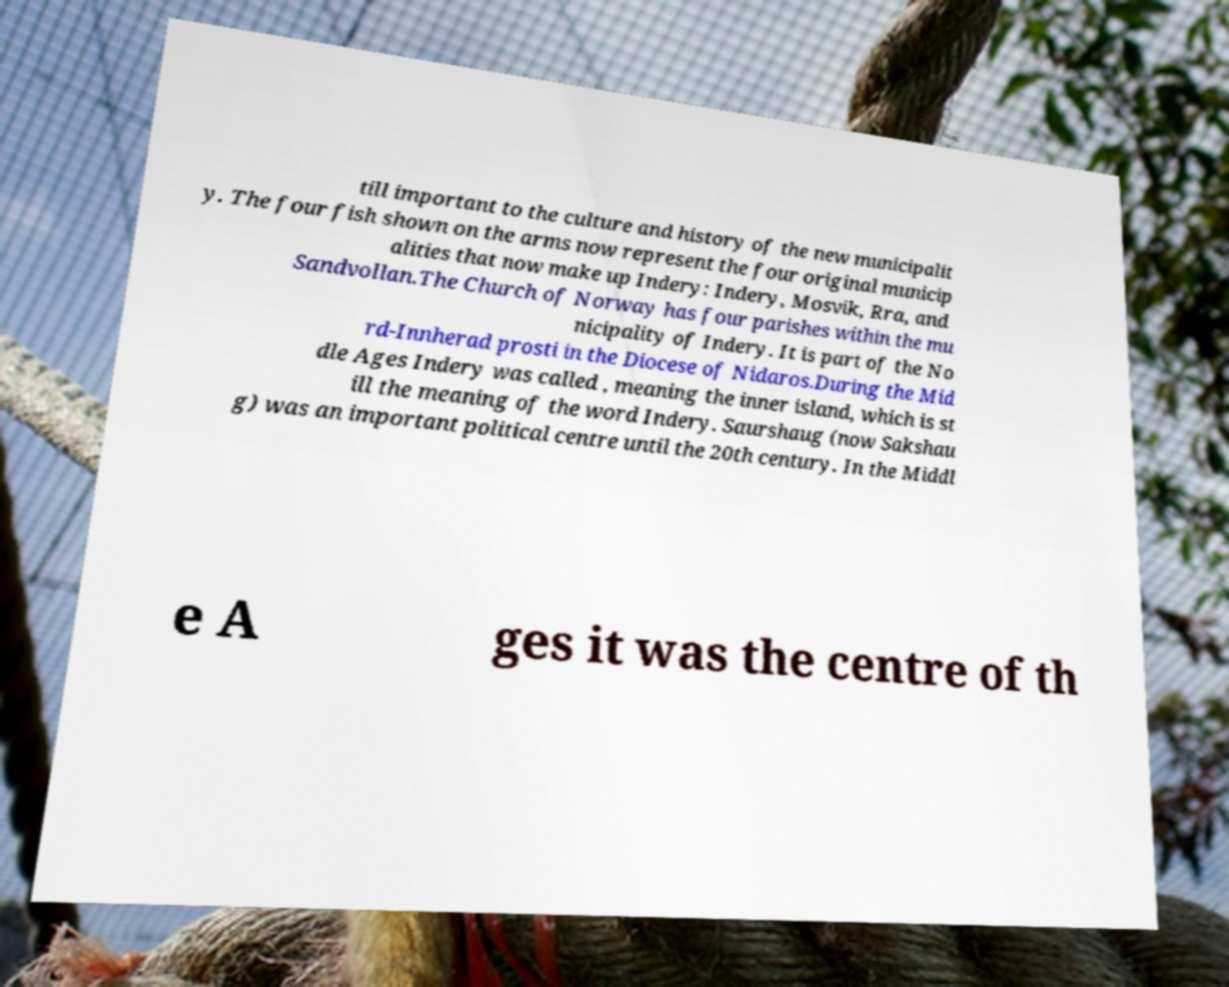For documentation purposes, I need the text within this image transcribed. Could you provide that? till important to the culture and history of the new municipalit y. The four fish shown on the arms now represent the four original municip alities that now make up Indery: Indery, Mosvik, Rra, and Sandvollan.The Church of Norway has four parishes within the mu nicipality of Indery. It is part of the No rd-Innherad prosti in the Diocese of Nidaros.During the Mid dle Ages Indery was called , meaning the inner island, which is st ill the meaning of the word Indery. Saurshaug (now Sakshau g) was an important political centre until the 20th century. In the Middl e A ges it was the centre of th 